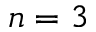Convert formula to latex. <formula><loc_0><loc_0><loc_500><loc_500>n = 3</formula> 